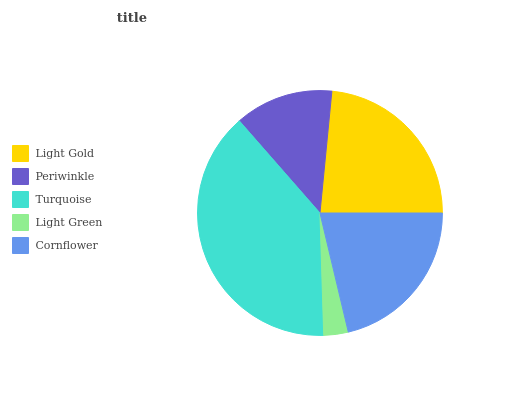Is Light Green the minimum?
Answer yes or no. Yes. Is Turquoise the maximum?
Answer yes or no. Yes. Is Periwinkle the minimum?
Answer yes or no. No. Is Periwinkle the maximum?
Answer yes or no. No. Is Light Gold greater than Periwinkle?
Answer yes or no. Yes. Is Periwinkle less than Light Gold?
Answer yes or no. Yes. Is Periwinkle greater than Light Gold?
Answer yes or no. No. Is Light Gold less than Periwinkle?
Answer yes or no. No. Is Cornflower the high median?
Answer yes or no. Yes. Is Cornflower the low median?
Answer yes or no. Yes. Is Light Green the high median?
Answer yes or no. No. Is Light Green the low median?
Answer yes or no. No. 